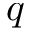Convert formula to latex. <formula><loc_0><loc_0><loc_500><loc_500>q</formula> 